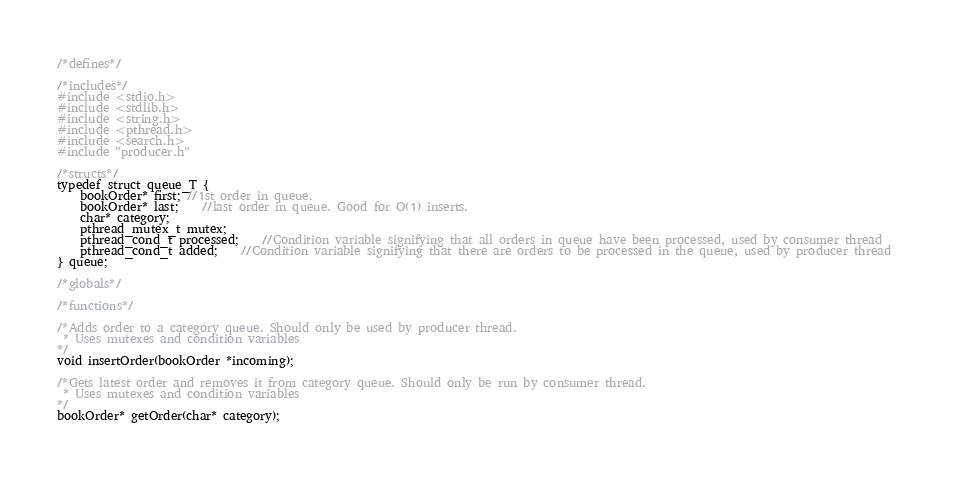<code> <loc_0><loc_0><loc_500><loc_500><_C_>/*defines*/

/*includes*/
#include <stdio.h>
#include <stdlib.h>
#include <string.h>
#include <pthread.h>
#include <search.h>
#include "producer.h"

/*structs*/
typedef struct queue_T {
	bookOrder* first; //1st order in queue.
	bookOrder* last;	//last order in queue. Good for O(1) inserts.
	char* category;
	pthread_mutex_t mutex;
	pthread_cond_t processed;	//Condition variable signifying that all orders in queue have been processed, used by consumer thread
	pthread_cond_t added;	//Condition variable signifying that there are orders to be processed in the queue, used by producer thread 
} queue;

/*globals*/

/*functions*/

/*Adds order to a category queue. Should only be used by producer thread.
 * Uses mutexes and condition variables
*/
void insertOrder(bookOrder *incoming);

/*Gets latest order and removes it from category queue. Should only be run by consumer thread.
 * Uses mutexes and condition variables
*/
bookOrder* getOrder(char* category);


</code> 